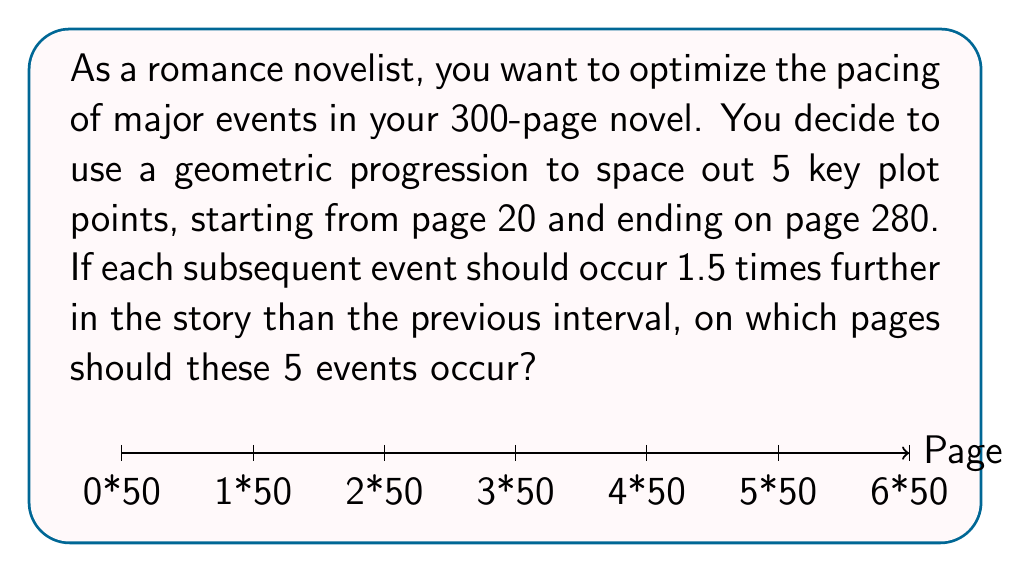Teach me how to tackle this problem. Let's approach this step-by-step:

1) We know that we have 5 events, with the first on page 20 and the last on page 280.

2) Let's define our geometric progression:
   $a_1 = 20$ (first term)
   $a_5 = 280$ (last term)
   $n = 5$ (number of terms)

3) In a geometric progression, each term is 1.5 times further from the previous term. This means our common ratio $r = 1.5$.

4) We can use the formula for the nth term of a geometric progression:
   $a_n = a_1 \cdot r^{n-1}$

5) Substituting our known values:
   $280 = 20 \cdot 1.5^{5-1}$
   $280 = 20 \cdot 1.5^4$

6) Now, we can calculate each term:
   $a_1 = 20$
   $a_2 = 20 \cdot 1.5^1 = 30$
   $a_3 = 20 \cdot 1.5^2 = 45$
   $a_4 = 20 \cdot 1.5^3 = 67.5$
   $a_5 = 20 \cdot 1.5^4 = 101.25$

7) However, we need to adjust these to fit our 280-page constraint. We can do this by scaling:
   $\text{Scaling factor} = \frac{280 - 20}{101.25 - 20} = 3.1951$

8) Applying this scaling factor to our progression:
   $a_1 = 20$
   $a_2 = 20 + (30 - 20) \cdot 3.1951 \approx 52$
   $a_3 = 20 + (45 - 20) \cdot 3.1951 \approx 100$
   $a_4 = 20 + (67.5 - 20) \cdot 3.1951 \approx 172$
   $a_5 = 280$

9) Rounding to the nearest page number, our events should occur on pages 20, 52, 100, 172, and 280.
Answer: Pages 20, 52, 100, 172, 280 